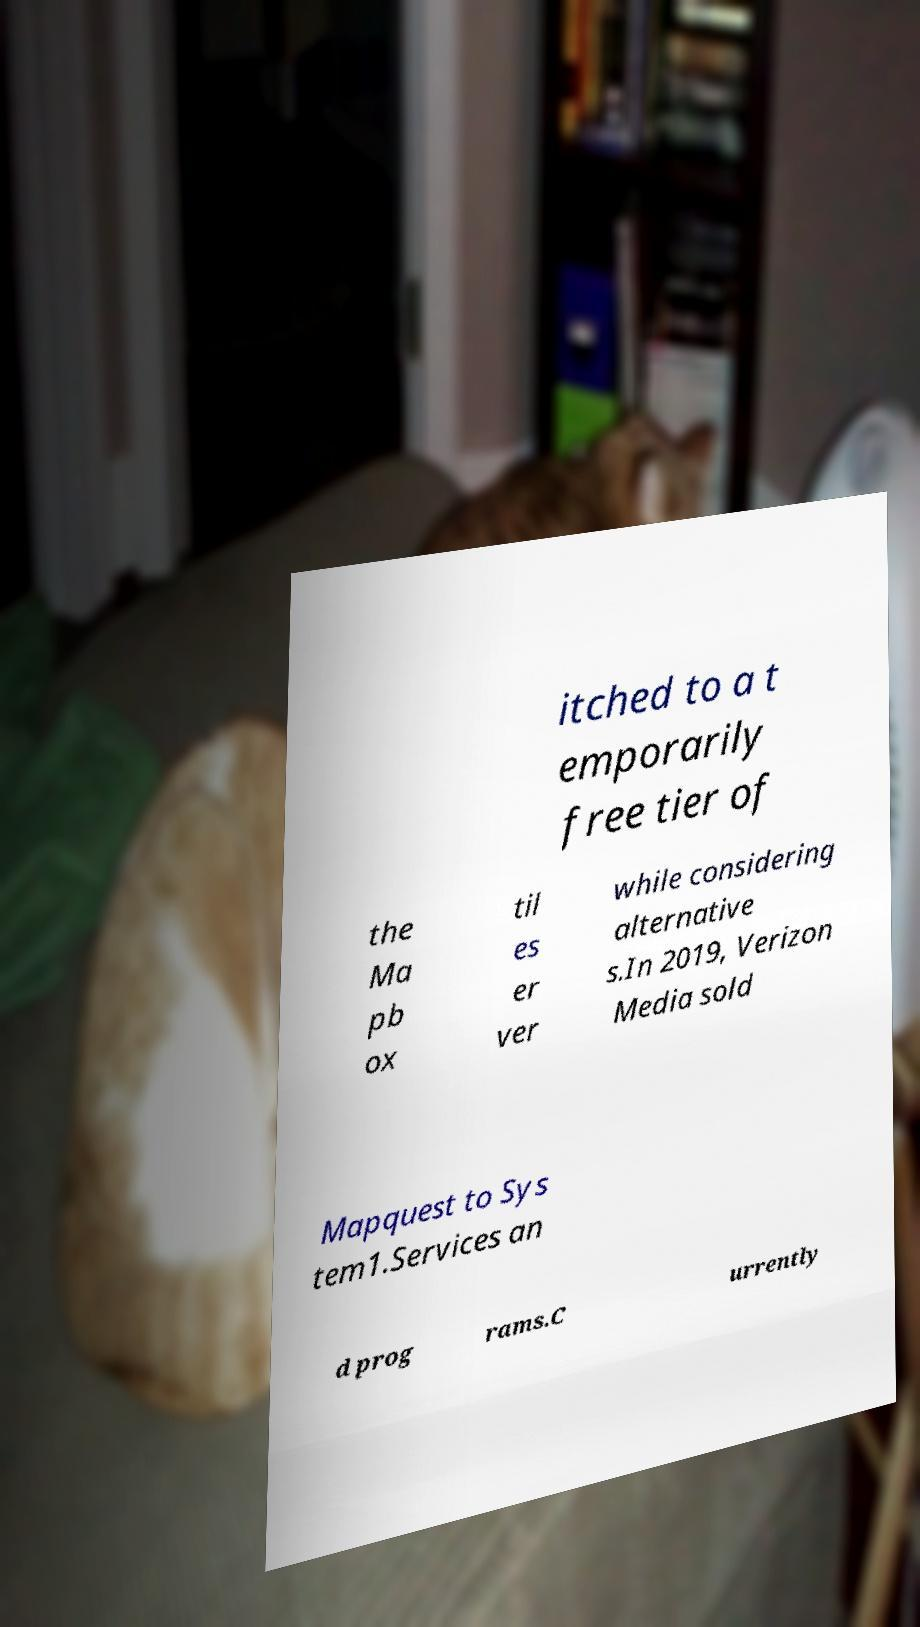There's text embedded in this image that I need extracted. Can you transcribe it verbatim? itched to a t emporarily free tier of the Ma pb ox til es er ver while considering alternative s.In 2019, Verizon Media sold Mapquest to Sys tem1.Services an d prog rams.C urrently 